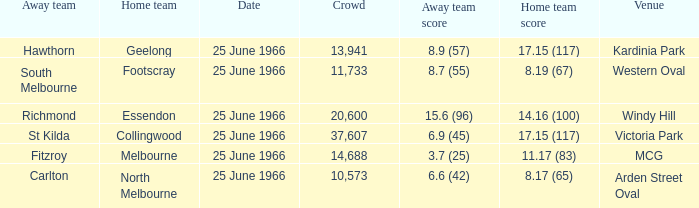Where did the away team score 8.7 (55)? Western Oval. 